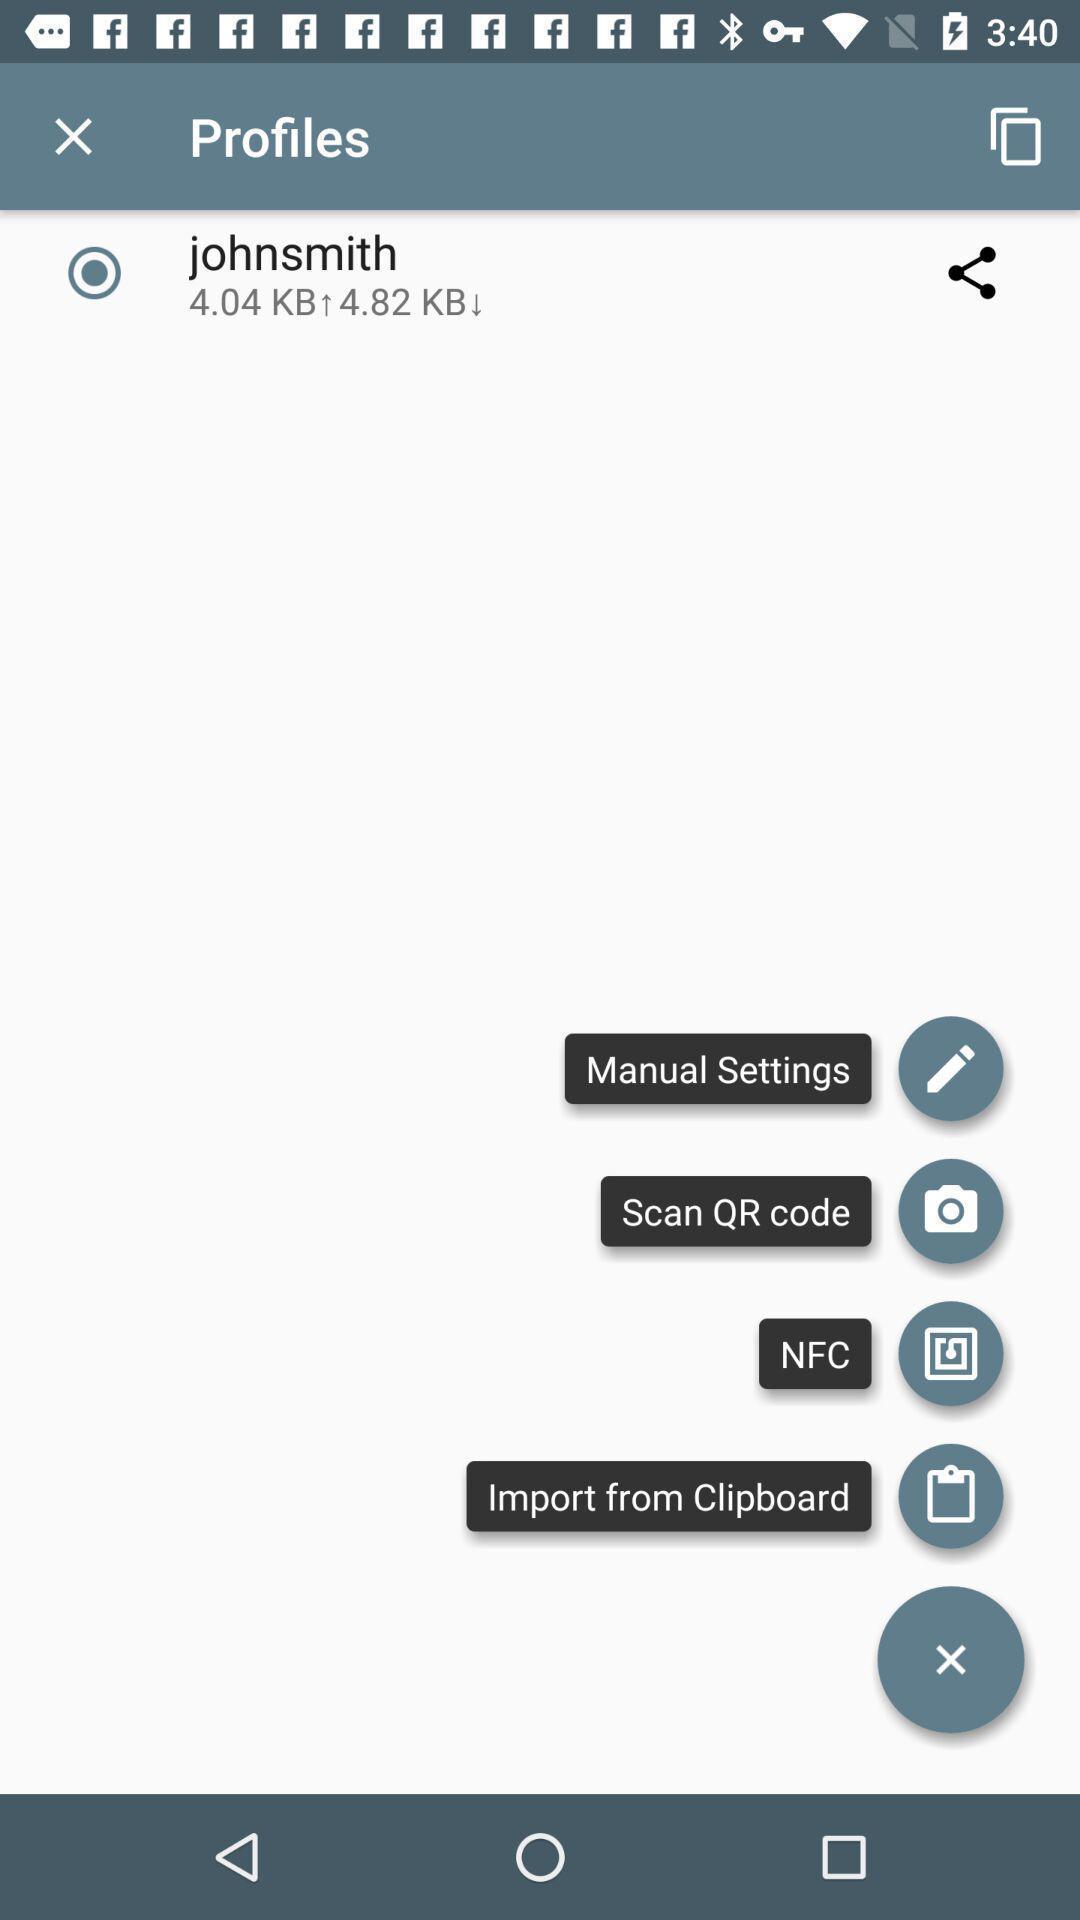Explain the elements present in this screenshot. Screen displaying the icons and its functions. 